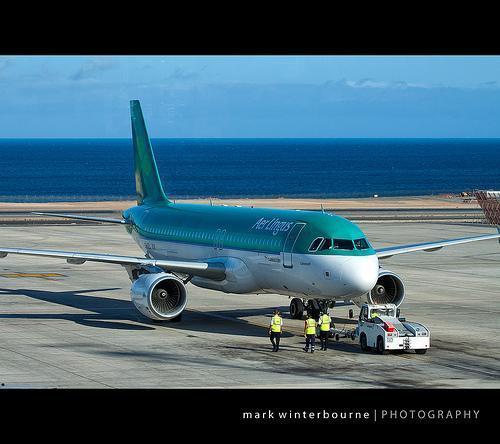How many workers do you see?
Give a very brief answer. 3. 